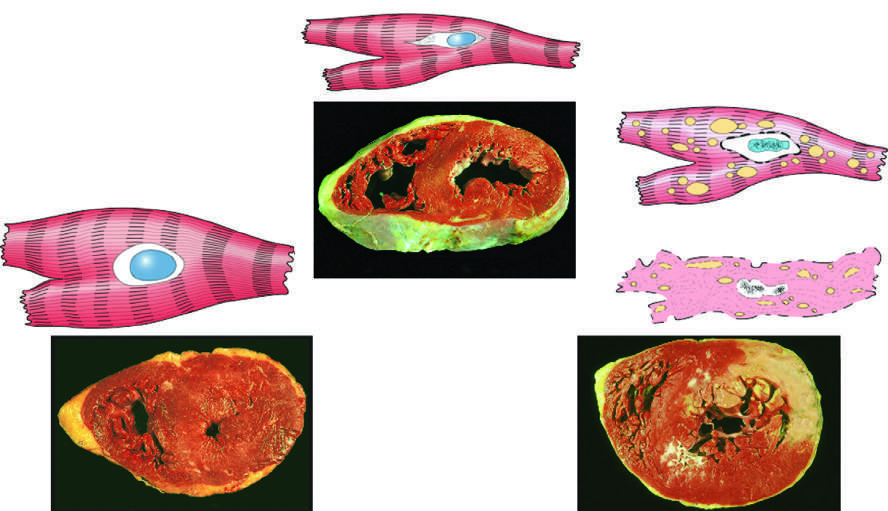does the transmural light area in the posterolateral left ventricle represent an acute myocardial infarction in the specimen showing necrosis?
Answer the question using a single word or phrase. Yes 